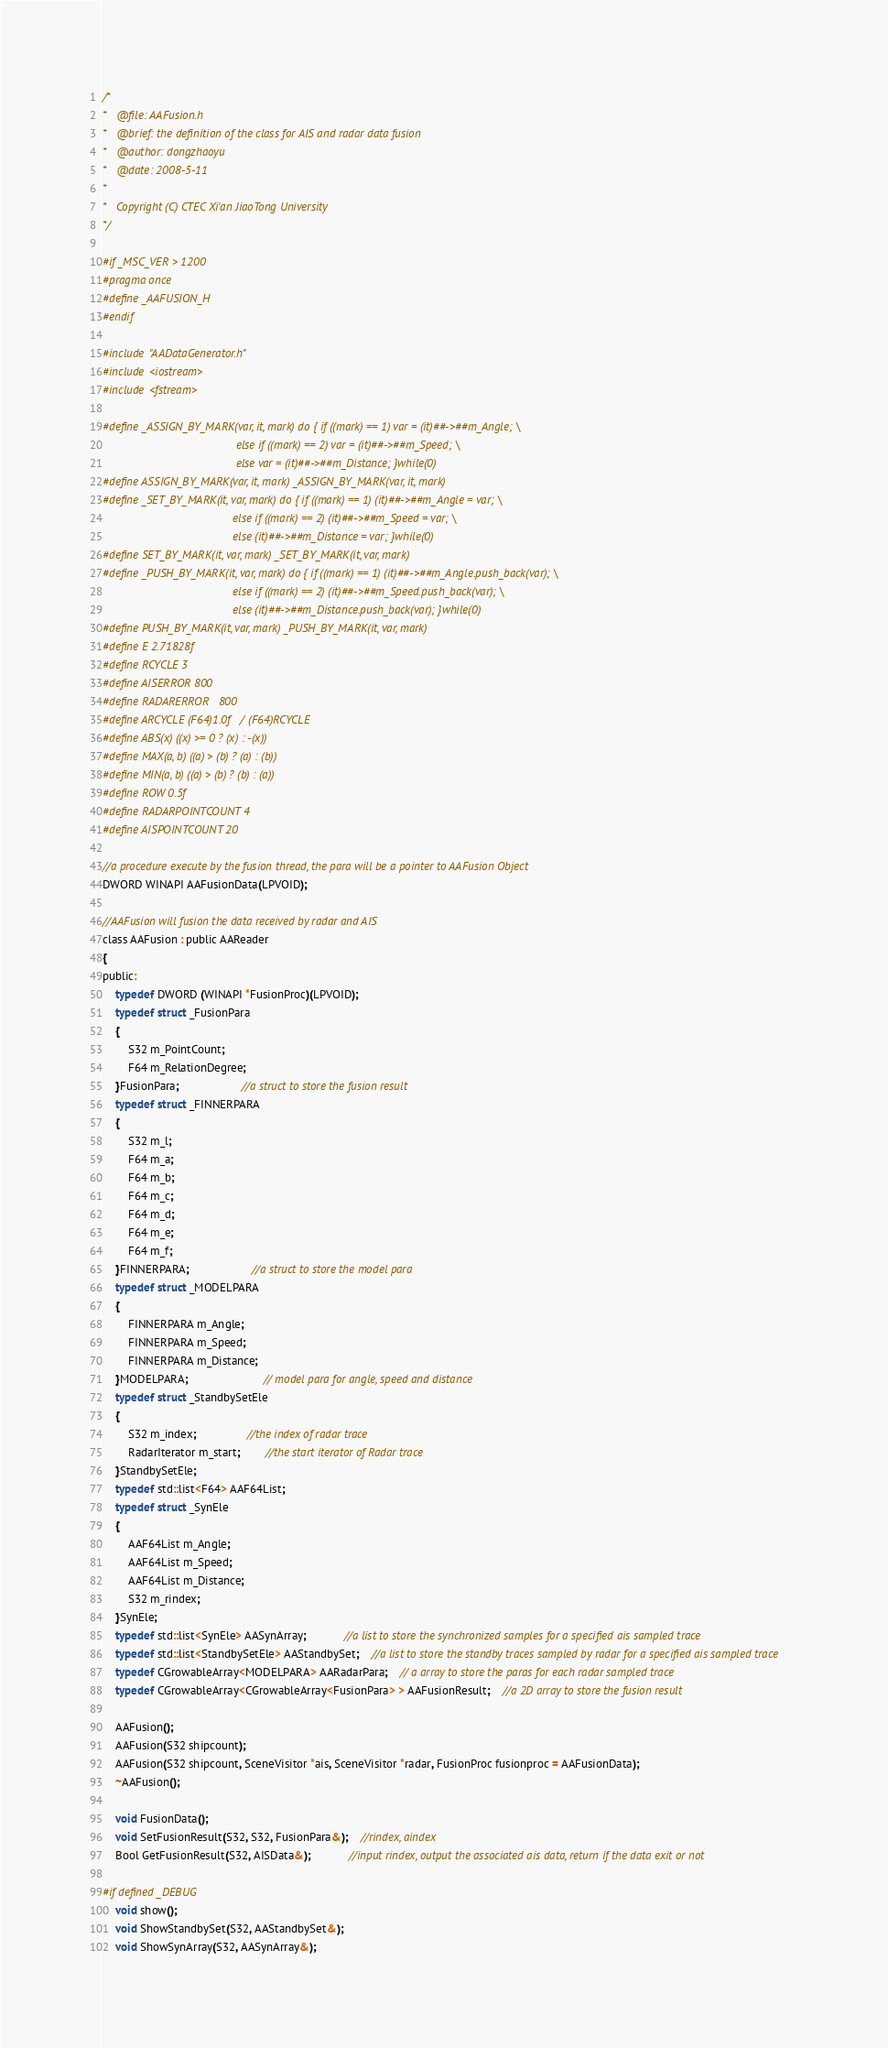Convert code to text. <code><loc_0><loc_0><loc_500><loc_500><_C_>/*
*	@file: AAFusion.h
*	@brief: the definition of the class for AIS and radar data fusion
*	@author: dongzhaoyu
*	@date: 2008-5-11
*
*	Copyright (C) CTEC Xi'an JiaoTong University
*/

#if _MSC_VER > 1200
#pragma once
#define _AAFUSION_H
#endif

#include "AADataGenerator.h"
#include <iostream>
#include <fstream>

#define _ASSIGN_BY_MARK(var, it, mark) do { if ((mark) == 1) var = (it)##->##m_Angle; \
										  else if ((mark) == 2) var = (it)##->##m_Speed; \
										  else var = (it)##->##m_Distance; }while(0)
#define ASSIGN_BY_MARK(var, it, mark) _ASSIGN_BY_MARK(var, it, mark)
#define _SET_BY_MARK(it, var, mark) do { if ((mark) == 1) (it)##->##m_Angle = var; \
										 else if ((mark) == 2) (it)##->##m_Speed = var; \
										 else (it)##->##m_Distance = var; }while(0)
#define SET_BY_MARK(it, var, mark) _SET_BY_MARK(it, var, mark)
#define _PUSH_BY_MARK(it, var, mark) do { if ((mark) == 1) (it)##->##m_Angle.push_back(var); \
										 else if ((mark) == 2) (it)##->##m_Speed.push_back(var); \
										 else (it)##->##m_Distance.push_back(var); }while(0)
#define PUSH_BY_MARK(it, var, mark) _PUSH_BY_MARK(it, var, mark)
#define E 2.71828f
#define RCYCLE 3
#define AISERROR	800
#define RADARERROR	800
#define ARCYCLE (F64)1.0f / (F64)RCYCLE
#define ABS(x) ((x) >= 0 ? (x) : -(x))
#define MAX(a, b) ((a) > (b) ? (a) : (b))
#define MIN(a, b) ((a) > (b) ? (b) : (a))
#define ROW 0.5f
#define RADARPOINTCOUNT 4
#define AISPOINTCOUNT 20

//a procedure execute by the fusion thread, the para will be a pointer to AAFusion Object
DWORD WINAPI AAFusionData(LPVOID);

//AAFusion will fusion the data received by radar and AIS
class AAFusion : public AAReader
{
public:
	typedef DWORD (WINAPI *FusionProc)(LPVOID);
	typedef struct _FusionPara
	{
		S32 m_PointCount;
		F64 m_RelationDegree;
	}FusionPara;					//a struct to store the fusion result
	typedef struct _FINNERPARA
	{
		S32 m_l;
		F64 m_a;
		F64 m_b;
		F64 m_c;
		F64 m_d;
		F64 m_e;
		F64 m_f;
	}FINNERPARA;					//a struct to store the model para
	typedef struct _MODELPARA
	{
		FINNERPARA m_Angle;
		FINNERPARA m_Speed;
		FINNERPARA m_Distance;
	}MODELPARA;						// model para for angle, speed and distance
	typedef struct _StandbySetEle
	{
		S32 m_index;				//the index of radar trace
		RadarIterator m_start;		//the start iterator of Radar trace
	}StandbySetEle;
	typedef std::list<F64> AAF64List;
	typedef struct _SynEle
	{
		AAF64List m_Angle;
		AAF64List m_Speed;
		AAF64List m_Distance;
		S32 m_rindex;
	}SynEle;
	typedef std::list<SynEle> AASynArray;			//a list to store the synchronized samples for a specified ais sampled trace
	typedef std::list<StandbySetEle> AAStandbySet;	//a list to store the standby traces sampled by radar for a specified ais sampled trace
	typedef CGrowableArray<MODELPARA> AARadarPara;	// a array to store the paras for each radar sampled trace
	typedef CGrowableArray<CGrowableArray<FusionPara> > AAFusionResult;	//a 2D array to store the fusion result

	AAFusion();
	AAFusion(S32 shipcount);
	AAFusion(S32 shipcount, SceneVisitor *ais, SceneVisitor *radar, FusionProc fusionproc = AAFusionData);
	~AAFusion();

	void FusionData();
	void SetFusionResult(S32, S32, FusionPara&);	//rindex, aindex
	Bool GetFusionResult(S32, AISData&);			//input rindex, output the associated ais data, return if the data exit or not

#if defined _DEBUG
	void show();
	void ShowStandbySet(S32, AAStandbySet&);
	void ShowSynArray(S32, AASynArray&);</code> 